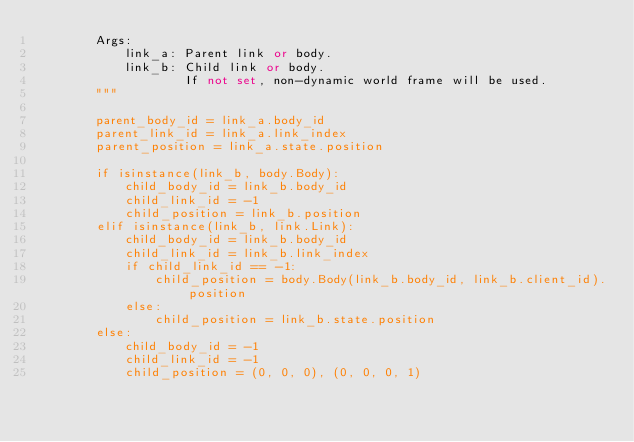<code> <loc_0><loc_0><loc_500><loc_500><_Python_>        Args:
            link_a: Parent link or body.
            link_b: Child link or body.
                    If not set, non-dynamic world frame will be used.
        """

        parent_body_id = link_a.body_id
        parent_link_id = link_a.link_index
        parent_position = link_a.state.position

        if isinstance(link_b, body.Body):
            child_body_id = link_b.body_id
            child_link_id = -1
            child_position = link_b.position
        elif isinstance(link_b, link.Link):
            child_body_id = link_b.body_id
            child_link_id = link_b.link_index
            if child_link_id == -1:
                child_position = body.Body(link_b.body_id, link_b.client_id).position
            else:
                child_position = link_b.state.position
        else:
            child_body_id = -1
            child_link_id = -1
            child_position = (0, 0, 0), (0, 0, 0, 1)
</code> 